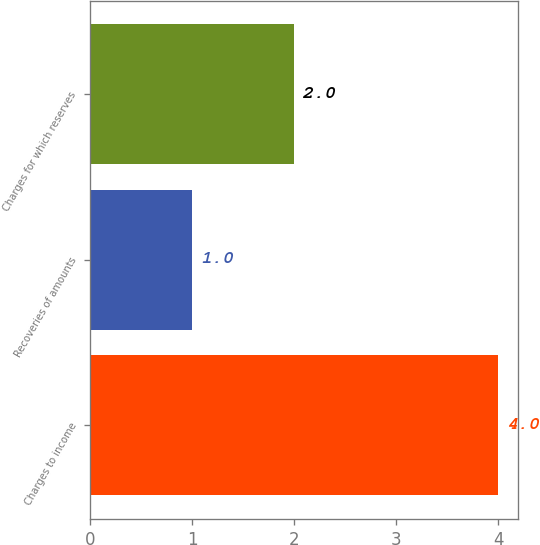Convert chart. <chart><loc_0><loc_0><loc_500><loc_500><bar_chart><fcel>Charges to income<fcel>Recoveries of amounts<fcel>Charges for which reserves<nl><fcel>4<fcel>1<fcel>2<nl></chart> 